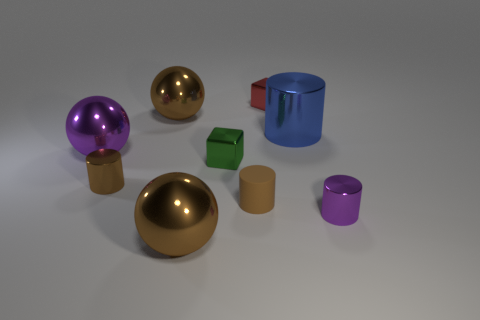How many red things are in front of the brown sphere that is behind the green object?
Provide a succinct answer. 0. There is a purple metallic object in front of the rubber cylinder; does it have the same size as the purple ball?
Make the answer very short. No. How many other rubber objects have the same shape as the blue object?
Provide a short and direct response. 1. What is the shape of the brown rubber object?
Your answer should be compact. Cylinder. Is the number of brown matte things on the right side of the red block the same as the number of rubber objects?
Provide a succinct answer. No. Is the brown thing on the right side of the green metallic thing made of the same material as the small purple object?
Offer a very short reply. No. Is the number of green shiny cubes behind the green metal cube less than the number of red metallic cubes?
Offer a terse response. Yes. How many metal objects are either tiny brown things or tiny cubes?
Offer a terse response. 3. Do the small rubber thing and the large cylinder have the same color?
Make the answer very short. No. Is there anything else that has the same color as the matte object?
Your answer should be very brief. Yes. 